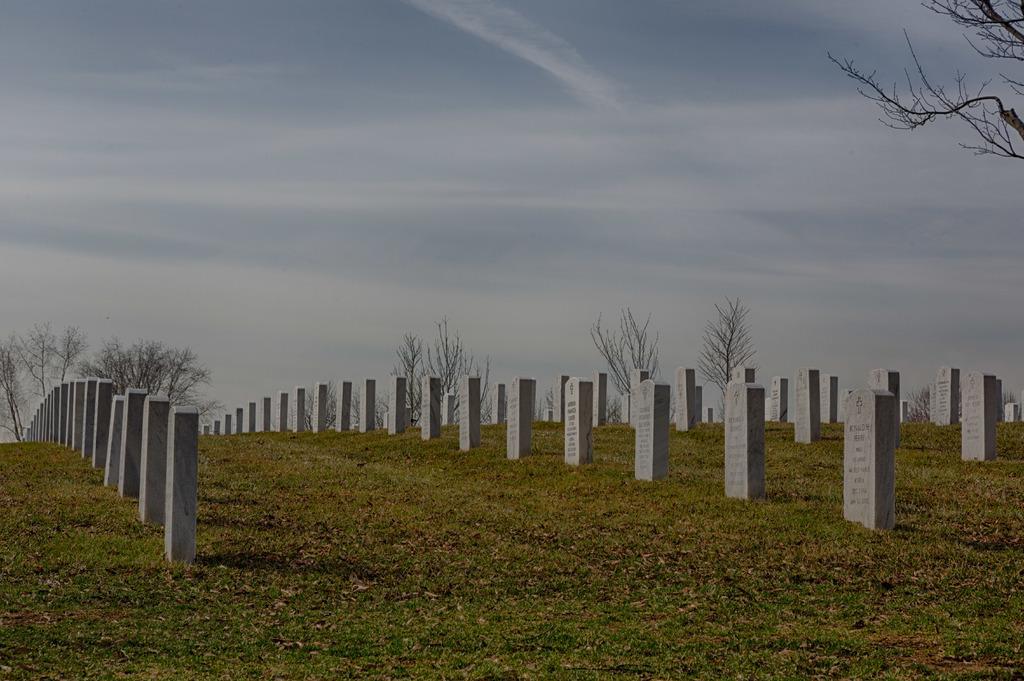Could you give a brief overview of what you see in this image? In this image we can see many memorial stones, grass, dry leaves, trees and the cloudy sky in the background. 